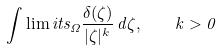Convert formula to latex. <formula><loc_0><loc_0><loc_500><loc_500>\int \lim i t s _ { \Omega } \frac { \delta ( \zeta ) } { | \zeta | ^ { k } } \, d \zeta , \quad k > 0</formula> 